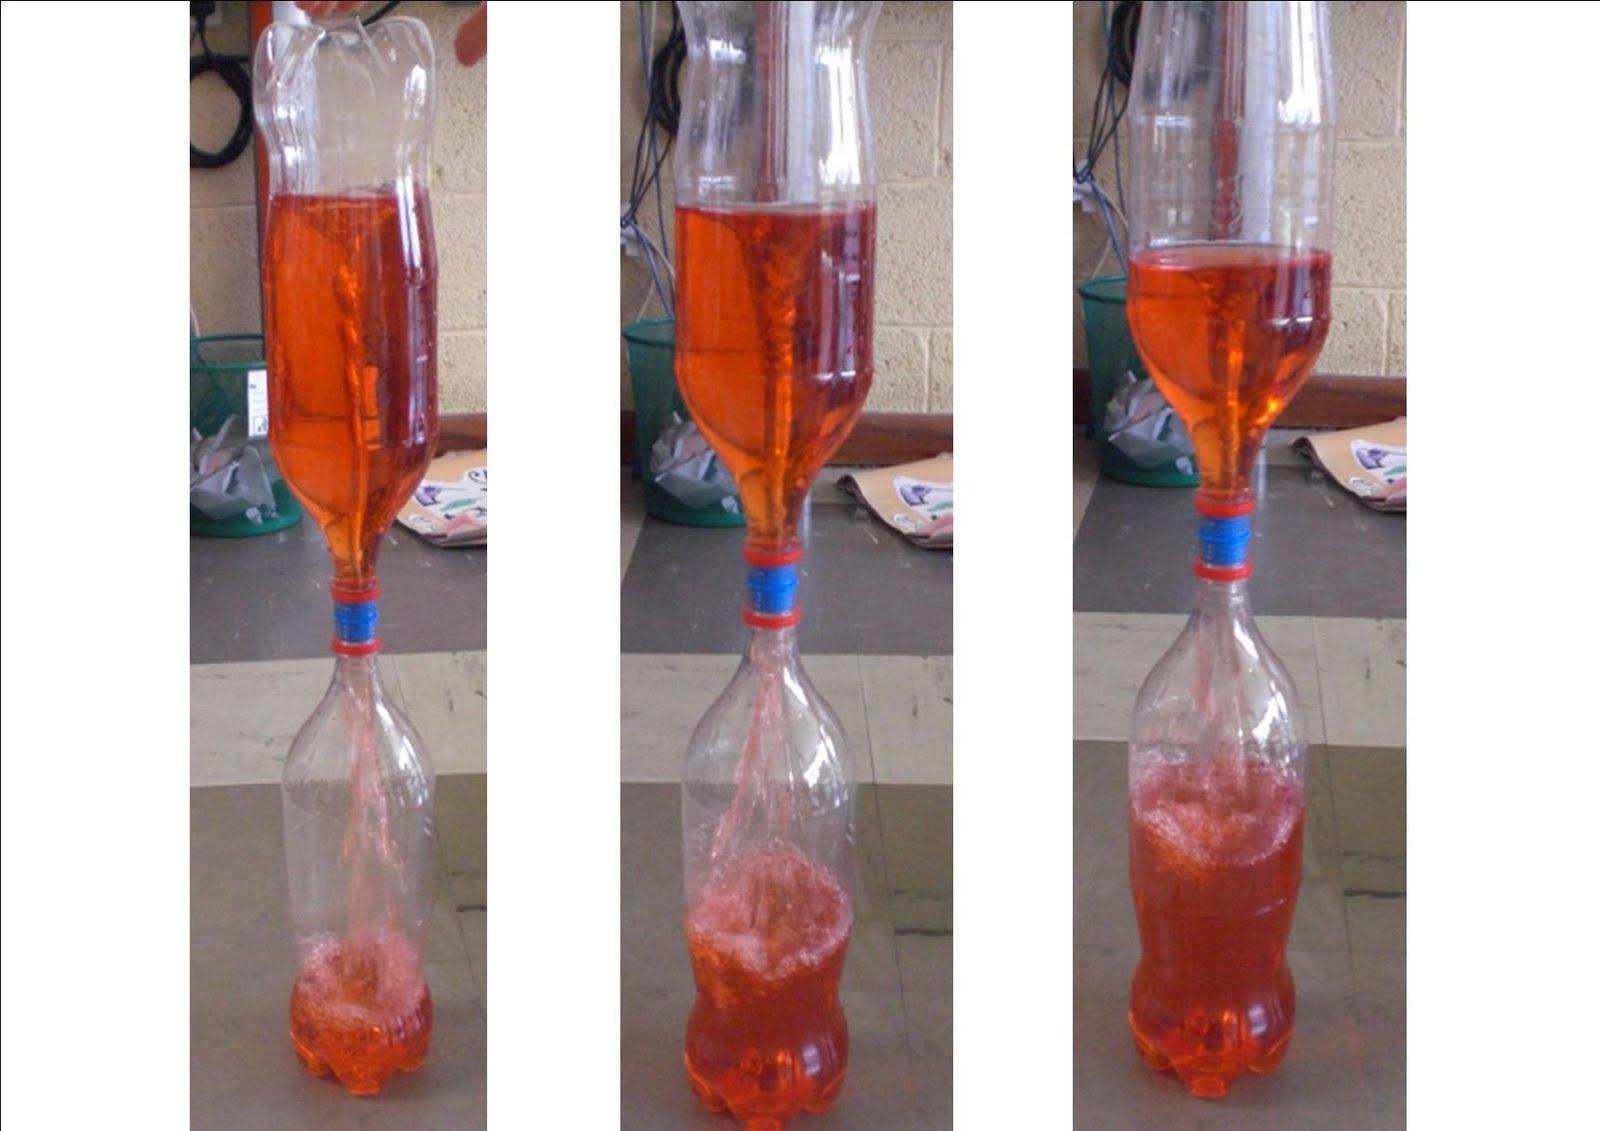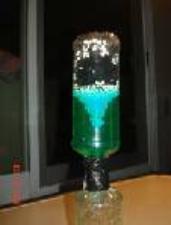The first image is the image on the left, the second image is the image on the right. Assess this claim about the two images: "In at least one image there is a make shift blue bottle funnel creating a mini tornado in blue water.". Correct or not? Answer yes or no. No. 